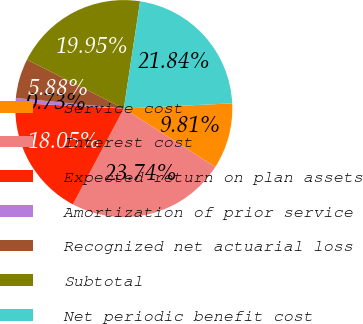Convert chart to OTSL. <chart><loc_0><loc_0><loc_500><loc_500><pie_chart><fcel>Service cost<fcel>Interest cost<fcel>Expected return on plan assets<fcel>Amortization of prior service<fcel>Recognized net actuarial loss<fcel>Subtotal<fcel>Net periodic benefit cost<nl><fcel>9.81%<fcel>23.74%<fcel>18.05%<fcel>0.73%<fcel>5.88%<fcel>19.95%<fcel>21.84%<nl></chart> 